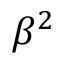<formula> <loc_0><loc_0><loc_500><loc_500>\beta ^ { 2 }</formula> 